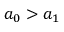Convert formula to latex. <formula><loc_0><loc_0><loc_500><loc_500>a _ { 0 } > a _ { 1 }</formula> 